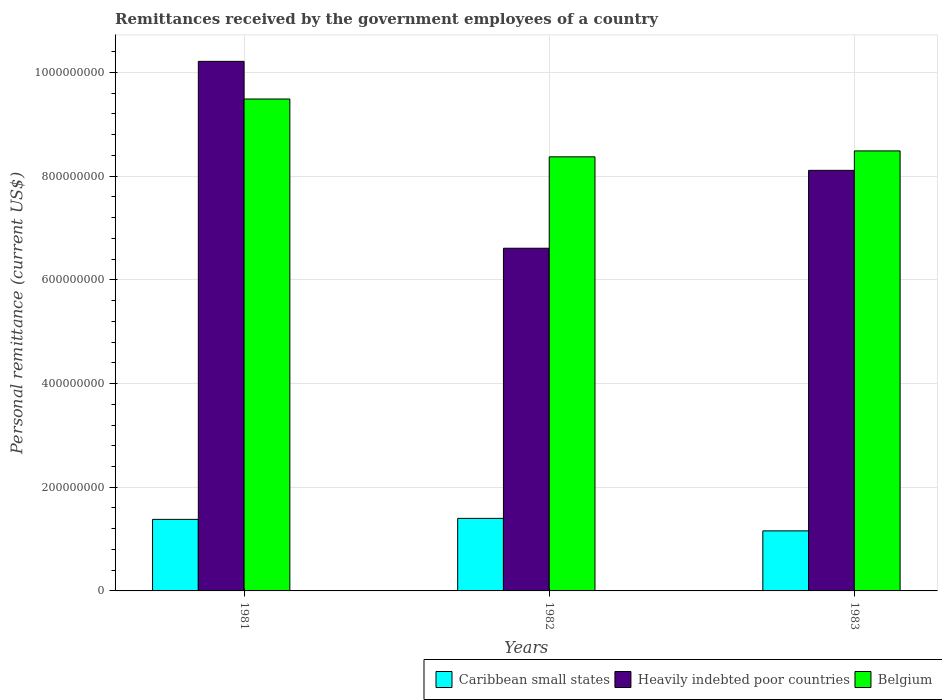How many different coloured bars are there?
Give a very brief answer. 3. Are the number of bars per tick equal to the number of legend labels?
Give a very brief answer. Yes. How many bars are there on the 2nd tick from the left?
Your response must be concise. 3. How many bars are there on the 1st tick from the right?
Your answer should be very brief. 3. What is the label of the 2nd group of bars from the left?
Ensure brevity in your answer.  1982. In how many cases, is the number of bars for a given year not equal to the number of legend labels?
Your answer should be very brief. 0. What is the remittances received by the government employees in Belgium in 1982?
Offer a terse response. 8.37e+08. Across all years, what is the maximum remittances received by the government employees in Caribbean small states?
Give a very brief answer. 1.40e+08. Across all years, what is the minimum remittances received by the government employees in Heavily indebted poor countries?
Ensure brevity in your answer.  6.61e+08. In which year was the remittances received by the government employees in Belgium maximum?
Give a very brief answer. 1981. In which year was the remittances received by the government employees in Belgium minimum?
Give a very brief answer. 1982. What is the total remittances received by the government employees in Belgium in the graph?
Offer a terse response. 2.63e+09. What is the difference between the remittances received by the government employees in Caribbean small states in 1981 and that in 1983?
Your answer should be compact. 2.22e+07. What is the difference between the remittances received by the government employees in Belgium in 1982 and the remittances received by the government employees in Caribbean small states in 1983?
Provide a succinct answer. 7.21e+08. What is the average remittances received by the government employees in Caribbean small states per year?
Provide a short and direct response. 1.31e+08. In the year 1982, what is the difference between the remittances received by the government employees in Belgium and remittances received by the government employees in Caribbean small states?
Ensure brevity in your answer.  6.97e+08. In how many years, is the remittances received by the government employees in Caribbean small states greater than 760000000 US$?
Your response must be concise. 0. What is the ratio of the remittances received by the government employees in Caribbean small states in 1981 to that in 1983?
Keep it short and to the point. 1.19. Is the difference between the remittances received by the government employees in Belgium in 1981 and 1983 greater than the difference between the remittances received by the government employees in Caribbean small states in 1981 and 1983?
Provide a succinct answer. Yes. What is the difference between the highest and the second highest remittances received by the government employees in Caribbean small states?
Provide a short and direct response. 1.96e+06. What is the difference between the highest and the lowest remittances received by the government employees in Caribbean small states?
Your answer should be compact. 2.41e+07. In how many years, is the remittances received by the government employees in Belgium greater than the average remittances received by the government employees in Belgium taken over all years?
Your response must be concise. 1. Is the sum of the remittances received by the government employees in Caribbean small states in 1982 and 1983 greater than the maximum remittances received by the government employees in Heavily indebted poor countries across all years?
Your response must be concise. No. What does the 2nd bar from the left in 1981 represents?
Offer a very short reply. Heavily indebted poor countries. What does the 1st bar from the right in 1981 represents?
Ensure brevity in your answer.  Belgium. Is it the case that in every year, the sum of the remittances received by the government employees in Heavily indebted poor countries and remittances received by the government employees in Belgium is greater than the remittances received by the government employees in Caribbean small states?
Provide a succinct answer. Yes. How many bars are there?
Offer a terse response. 9. Are all the bars in the graph horizontal?
Offer a terse response. No. How many years are there in the graph?
Offer a terse response. 3. What is the difference between two consecutive major ticks on the Y-axis?
Provide a short and direct response. 2.00e+08. Does the graph contain any zero values?
Offer a very short reply. No. Does the graph contain grids?
Offer a terse response. Yes. How are the legend labels stacked?
Give a very brief answer. Horizontal. What is the title of the graph?
Give a very brief answer. Remittances received by the government employees of a country. What is the label or title of the X-axis?
Make the answer very short. Years. What is the label or title of the Y-axis?
Offer a very short reply. Personal remittance (current US$). What is the Personal remittance (current US$) in Caribbean small states in 1981?
Provide a short and direct response. 1.38e+08. What is the Personal remittance (current US$) of Heavily indebted poor countries in 1981?
Provide a succinct answer. 1.02e+09. What is the Personal remittance (current US$) in Belgium in 1981?
Ensure brevity in your answer.  9.49e+08. What is the Personal remittance (current US$) of Caribbean small states in 1982?
Give a very brief answer. 1.40e+08. What is the Personal remittance (current US$) in Heavily indebted poor countries in 1982?
Offer a terse response. 6.61e+08. What is the Personal remittance (current US$) in Belgium in 1982?
Provide a short and direct response. 8.37e+08. What is the Personal remittance (current US$) of Caribbean small states in 1983?
Make the answer very short. 1.16e+08. What is the Personal remittance (current US$) in Heavily indebted poor countries in 1983?
Make the answer very short. 8.11e+08. What is the Personal remittance (current US$) of Belgium in 1983?
Your response must be concise. 8.49e+08. Across all years, what is the maximum Personal remittance (current US$) in Caribbean small states?
Provide a short and direct response. 1.40e+08. Across all years, what is the maximum Personal remittance (current US$) in Heavily indebted poor countries?
Your answer should be very brief. 1.02e+09. Across all years, what is the maximum Personal remittance (current US$) in Belgium?
Your answer should be very brief. 9.49e+08. Across all years, what is the minimum Personal remittance (current US$) of Caribbean small states?
Your answer should be compact. 1.16e+08. Across all years, what is the minimum Personal remittance (current US$) in Heavily indebted poor countries?
Provide a succinct answer. 6.61e+08. Across all years, what is the minimum Personal remittance (current US$) of Belgium?
Provide a succinct answer. 8.37e+08. What is the total Personal remittance (current US$) in Caribbean small states in the graph?
Your answer should be compact. 3.94e+08. What is the total Personal remittance (current US$) of Heavily indebted poor countries in the graph?
Give a very brief answer. 2.49e+09. What is the total Personal remittance (current US$) of Belgium in the graph?
Make the answer very short. 2.63e+09. What is the difference between the Personal remittance (current US$) of Caribbean small states in 1981 and that in 1982?
Ensure brevity in your answer.  -1.96e+06. What is the difference between the Personal remittance (current US$) in Heavily indebted poor countries in 1981 and that in 1982?
Provide a succinct answer. 3.61e+08. What is the difference between the Personal remittance (current US$) of Belgium in 1981 and that in 1982?
Provide a short and direct response. 1.12e+08. What is the difference between the Personal remittance (current US$) of Caribbean small states in 1981 and that in 1983?
Offer a terse response. 2.22e+07. What is the difference between the Personal remittance (current US$) in Heavily indebted poor countries in 1981 and that in 1983?
Make the answer very short. 2.10e+08. What is the difference between the Personal remittance (current US$) in Belgium in 1981 and that in 1983?
Your answer should be compact. 1.00e+08. What is the difference between the Personal remittance (current US$) of Caribbean small states in 1982 and that in 1983?
Ensure brevity in your answer.  2.41e+07. What is the difference between the Personal remittance (current US$) in Heavily indebted poor countries in 1982 and that in 1983?
Keep it short and to the point. -1.50e+08. What is the difference between the Personal remittance (current US$) of Belgium in 1982 and that in 1983?
Offer a very short reply. -1.14e+07. What is the difference between the Personal remittance (current US$) of Caribbean small states in 1981 and the Personal remittance (current US$) of Heavily indebted poor countries in 1982?
Your answer should be very brief. -5.23e+08. What is the difference between the Personal remittance (current US$) in Caribbean small states in 1981 and the Personal remittance (current US$) in Belgium in 1982?
Ensure brevity in your answer.  -6.99e+08. What is the difference between the Personal remittance (current US$) in Heavily indebted poor countries in 1981 and the Personal remittance (current US$) in Belgium in 1982?
Give a very brief answer. 1.84e+08. What is the difference between the Personal remittance (current US$) in Caribbean small states in 1981 and the Personal remittance (current US$) in Heavily indebted poor countries in 1983?
Give a very brief answer. -6.73e+08. What is the difference between the Personal remittance (current US$) in Caribbean small states in 1981 and the Personal remittance (current US$) in Belgium in 1983?
Your answer should be very brief. -7.11e+08. What is the difference between the Personal remittance (current US$) in Heavily indebted poor countries in 1981 and the Personal remittance (current US$) in Belgium in 1983?
Your answer should be compact. 1.73e+08. What is the difference between the Personal remittance (current US$) in Caribbean small states in 1982 and the Personal remittance (current US$) in Heavily indebted poor countries in 1983?
Keep it short and to the point. -6.71e+08. What is the difference between the Personal remittance (current US$) of Caribbean small states in 1982 and the Personal remittance (current US$) of Belgium in 1983?
Your answer should be compact. -7.09e+08. What is the difference between the Personal remittance (current US$) in Heavily indebted poor countries in 1982 and the Personal remittance (current US$) in Belgium in 1983?
Ensure brevity in your answer.  -1.88e+08. What is the average Personal remittance (current US$) of Caribbean small states per year?
Your response must be concise. 1.31e+08. What is the average Personal remittance (current US$) of Heavily indebted poor countries per year?
Make the answer very short. 8.31e+08. What is the average Personal remittance (current US$) in Belgium per year?
Ensure brevity in your answer.  8.78e+08. In the year 1981, what is the difference between the Personal remittance (current US$) in Caribbean small states and Personal remittance (current US$) in Heavily indebted poor countries?
Keep it short and to the point. -8.84e+08. In the year 1981, what is the difference between the Personal remittance (current US$) of Caribbean small states and Personal remittance (current US$) of Belgium?
Give a very brief answer. -8.11e+08. In the year 1981, what is the difference between the Personal remittance (current US$) of Heavily indebted poor countries and Personal remittance (current US$) of Belgium?
Ensure brevity in your answer.  7.26e+07. In the year 1982, what is the difference between the Personal remittance (current US$) of Caribbean small states and Personal remittance (current US$) of Heavily indebted poor countries?
Your answer should be very brief. -5.21e+08. In the year 1982, what is the difference between the Personal remittance (current US$) of Caribbean small states and Personal remittance (current US$) of Belgium?
Your answer should be compact. -6.97e+08. In the year 1982, what is the difference between the Personal remittance (current US$) of Heavily indebted poor countries and Personal remittance (current US$) of Belgium?
Provide a short and direct response. -1.76e+08. In the year 1983, what is the difference between the Personal remittance (current US$) of Caribbean small states and Personal remittance (current US$) of Heavily indebted poor countries?
Provide a succinct answer. -6.95e+08. In the year 1983, what is the difference between the Personal remittance (current US$) in Caribbean small states and Personal remittance (current US$) in Belgium?
Your response must be concise. -7.33e+08. In the year 1983, what is the difference between the Personal remittance (current US$) of Heavily indebted poor countries and Personal remittance (current US$) of Belgium?
Provide a short and direct response. -3.75e+07. What is the ratio of the Personal remittance (current US$) in Heavily indebted poor countries in 1981 to that in 1982?
Offer a terse response. 1.55. What is the ratio of the Personal remittance (current US$) of Belgium in 1981 to that in 1982?
Keep it short and to the point. 1.13. What is the ratio of the Personal remittance (current US$) of Caribbean small states in 1981 to that in 1983?
Your answer should be compact. 1.19. What is the ratio of the Personal remittance (current US$) in Heavily indebted poor countries in 1981 to that in 1983?
Provide a short and direct response. 1.26. What is the ratio of the Personal remittance (current US$) of Belgium in 1981 to that in 1983?
Keep it short and to the point. 1.12. What is the ratio of the Personal remittance (current US$) in Caribbean small states in 1982 to that in 1983?
Provide a succinct answer. 1.21. What is the ratio of the Personal remittance (current US$) of Heavily indebted poor countries in 1982 to that in 1983?
Offer a very short reply. 0.81. What is the ratio of the Personal remittance (current US$) in Belgium in 1982 to that in 1983?
Provide a short and direct response. 0.99. What is the difference between the highest and the second highest Personal remittance (current US$) in Caribbean small states?
Your answer should be compact. 1.96e+06. What is the difference between the highest and the second highest Personal remittance (current US$) of Heavily indebted poor countries?
Your answer should be very brief. 2.10e+08. What is the difference between the highest and the second highest Personal remittance (current US$) in Belgium?
Your response must be concise. 1.00e+08. What is the difference between the highest and the lowest Personal remittance (current US$) in Caribbean small states?
Give a very brief answer. 2.41e+07. What is the difference between the highest and the lowest Personal remittance (current US$) in Heavily indebted poor countries?
Ensure brevity in your answer.  3.61e+08. What is the difference between the highest and the lowest Personal remittance (current US$) in Belgium?
Ensure brevity in your answer.  1.12e+08. 